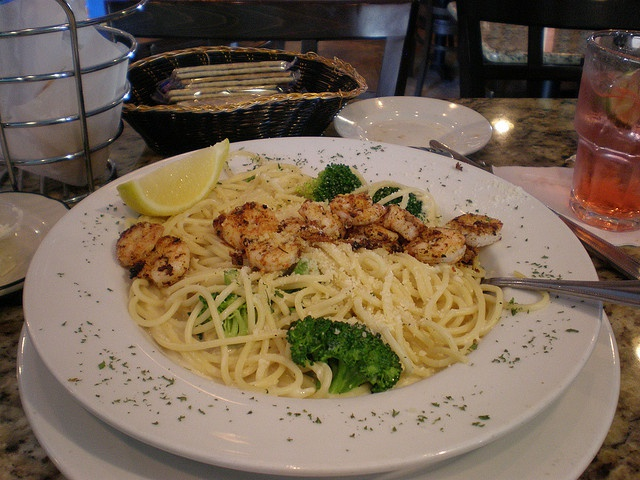Describe the objects in this image and their specific colors. I can see bowl in navy, darkgray, tan, and olive tones, cup in navy, maroon, and black tones, broccoli in navy, darkgreen, and tan tones, fork in navy, gray, and black tones, and spoon in navy, gray, and black tones in this image. 